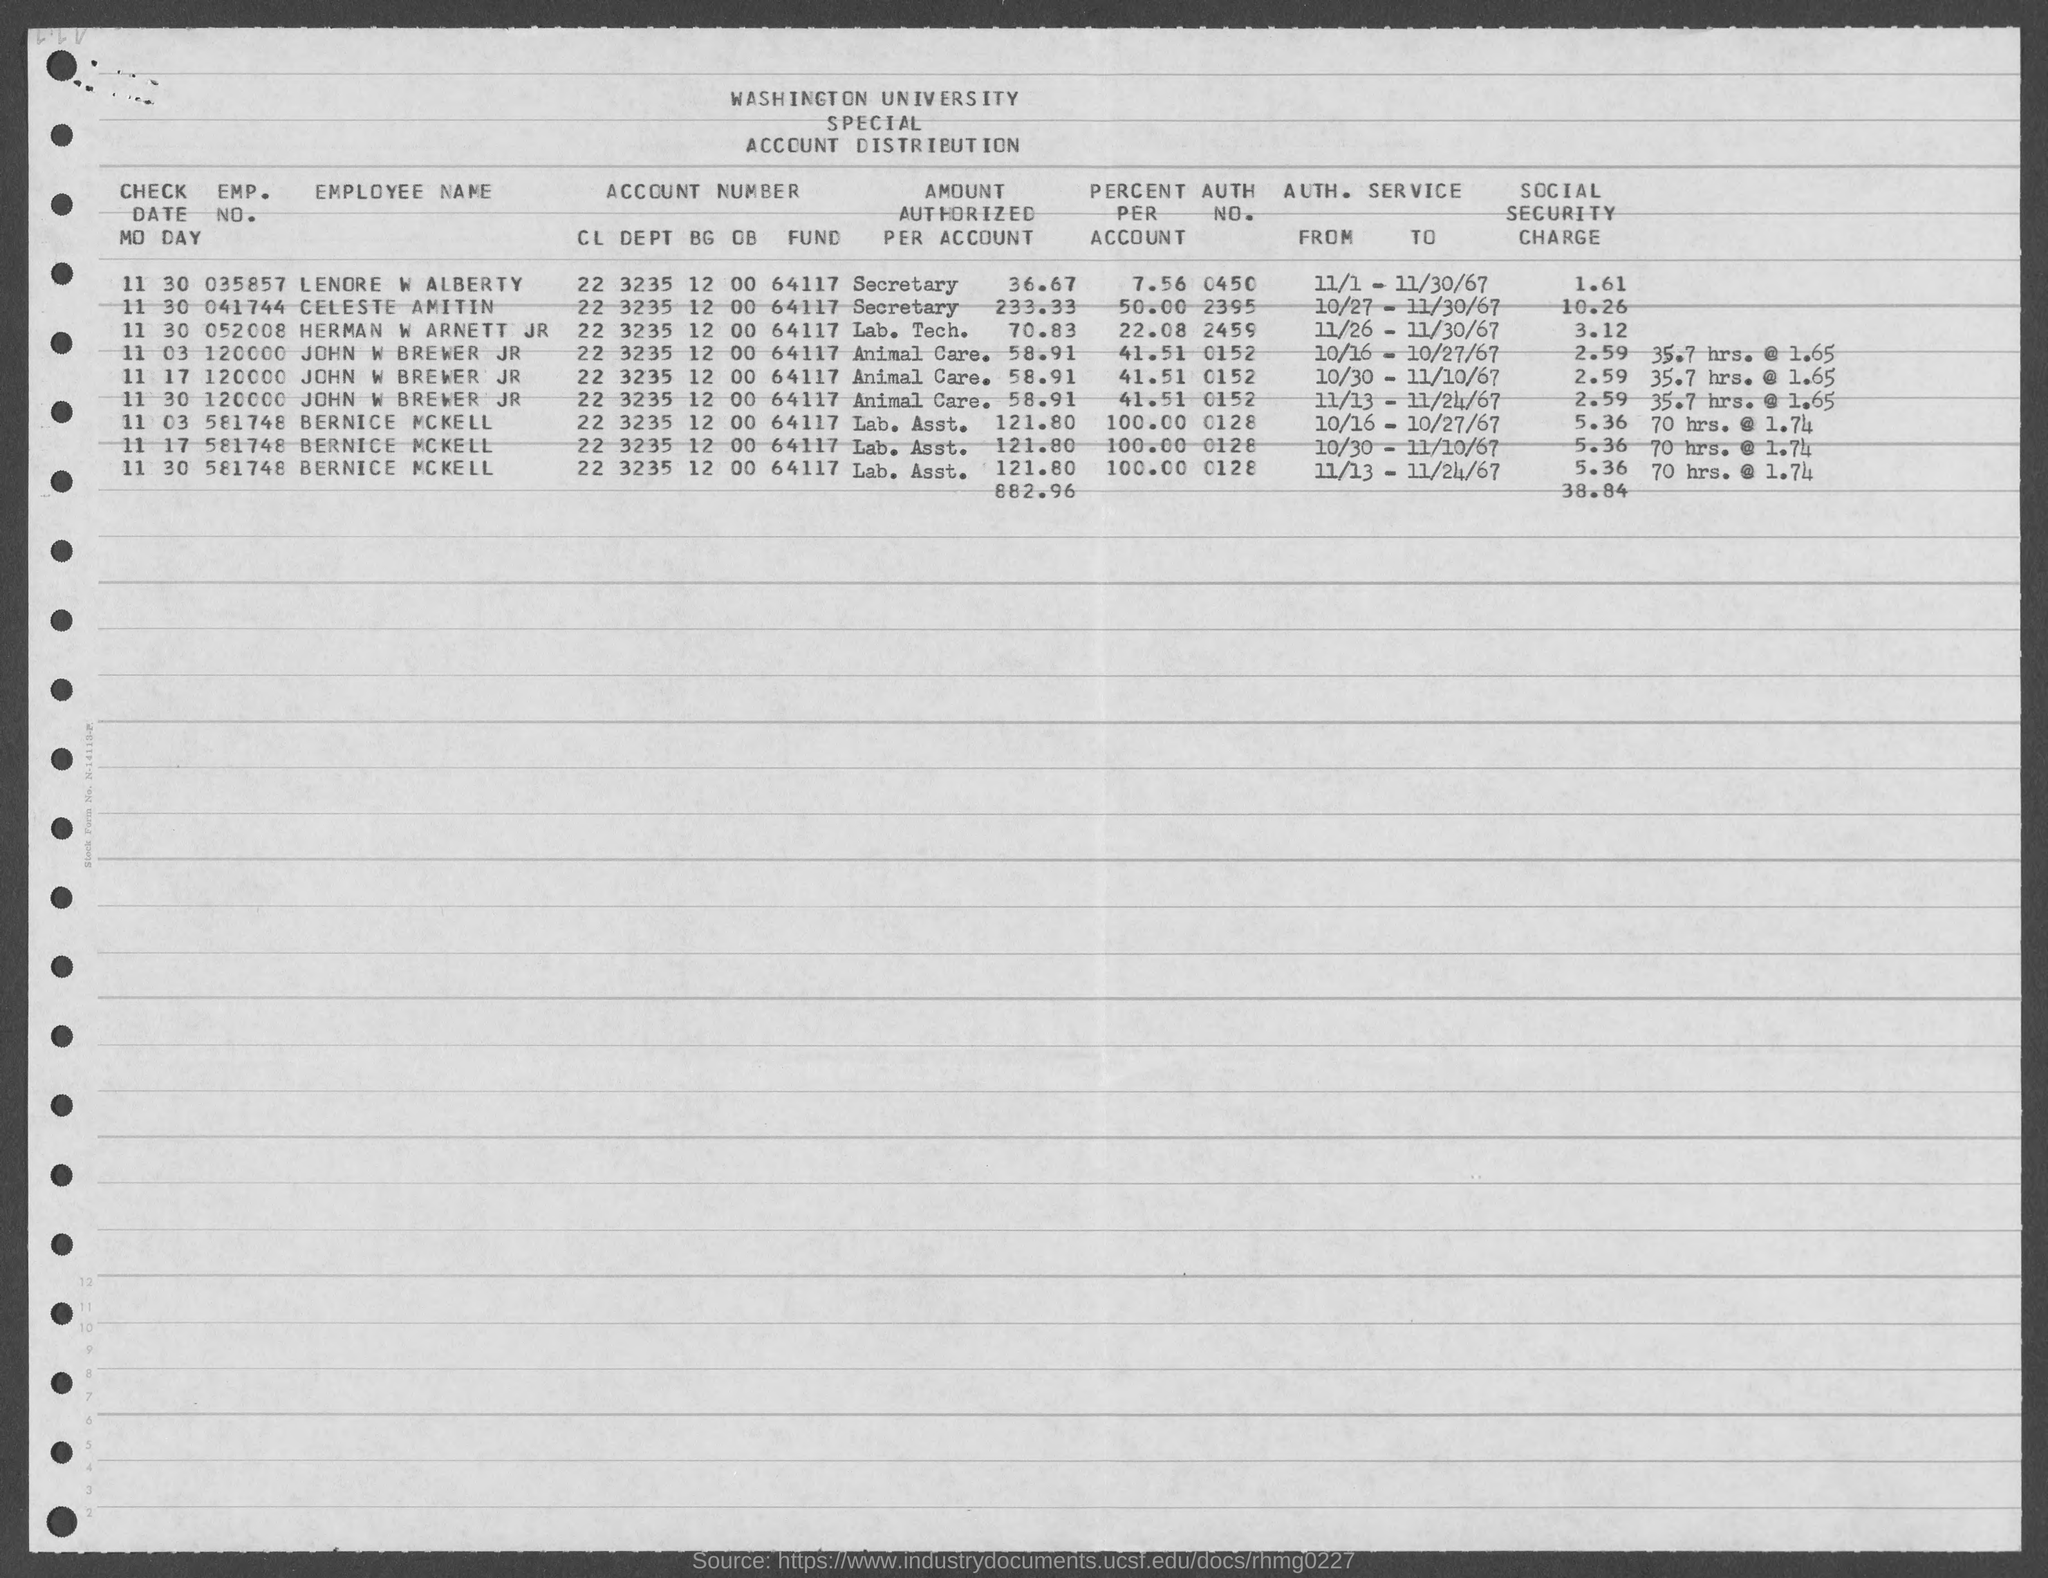What is the emp. no. of lenore w alberty ?
Ensure brevity in your answer.  035857. What is the emp. no. of celeste amitin ?
Your response must be concise. 041744. What is the emp. no. of herman w arnett jr ?
Offer a very short reply. 052008. What is the emp. no. of john w brewer jr ?
Provide a succinct answer. 120000. What is the emp. no. of bernice mckell ?
Offer a terse response. 581748. What is the auth. no. of lenore w alberty ?
Give a very brief answer. 0450. What is the auth. no. celeste amitin ?
Keep it short and to the point. 2395. What is the auth. no. of herman w arnett jr?
Give a very brief answer. 2459. What is the auth. no. of John W Brewer Jr ?
Your answer should be compact. 0152. What is the auth. no. of bernice mckell?
Give a very brief answer. 0128. 